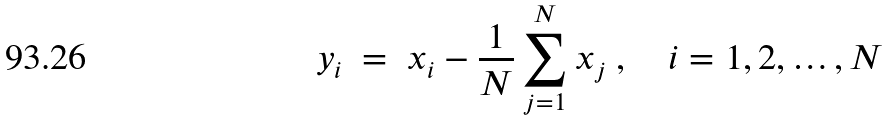Convert formula to latex. <formula><loc_0><loc_0><loc_500><loc_500>y _ { i } \ = \ x _ { i } - \frac { 1 } { N } \sum _ { j = 1 } ^ { N } x _ { j } \ , \quad i = 1 , 2 , \dots , N</formula> 